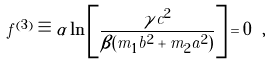<formula> <loc_0><loc_0><loc_500><loc_500>f ^ { ( 3 ) } \equiv \alpha \ln \left [ \frac { \gamma c ^ { 2 } } { \beta ( m _ { 1 } b ^ { 2 } + m _ { 2 } a ^ { 2 } ) } \right ] = 0 \ ,</formula> 